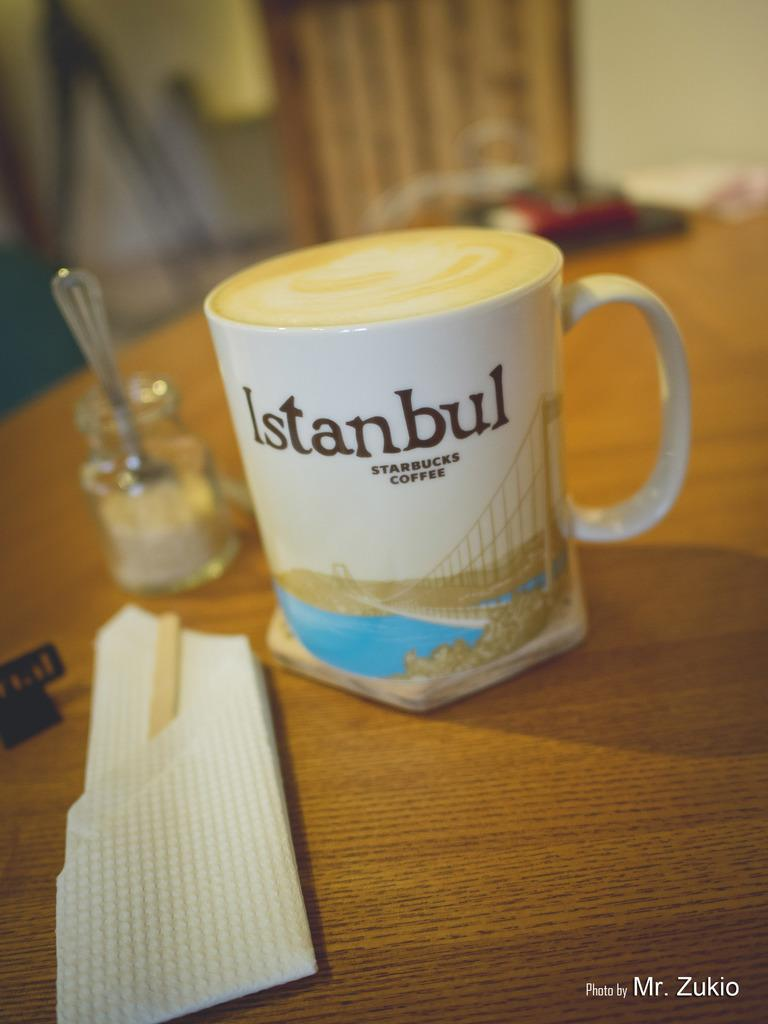Provide a one-sentence caption for the provided image. A Starbucks Coffee cup with a scene from Istanbul on it sits on a wooden table. 